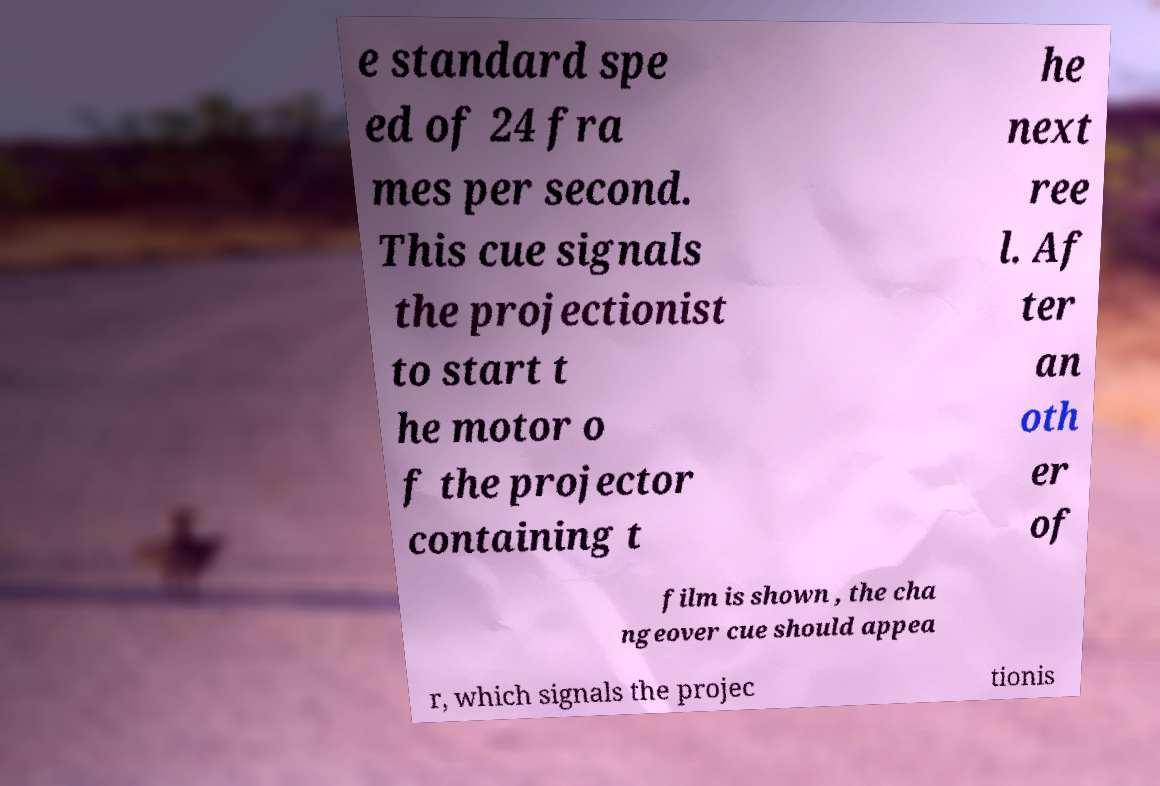There's text embedded in this image that I need extracted. Can you transcribe it verbatim? e standard spe ed of 24 fra mes per second. This cue signals the projectionist to start t he motor o f the projector containing t he next ree l. Af ter an oth er of film is shown , the cha ngeover cue should appea r, which signals the projec tionis 